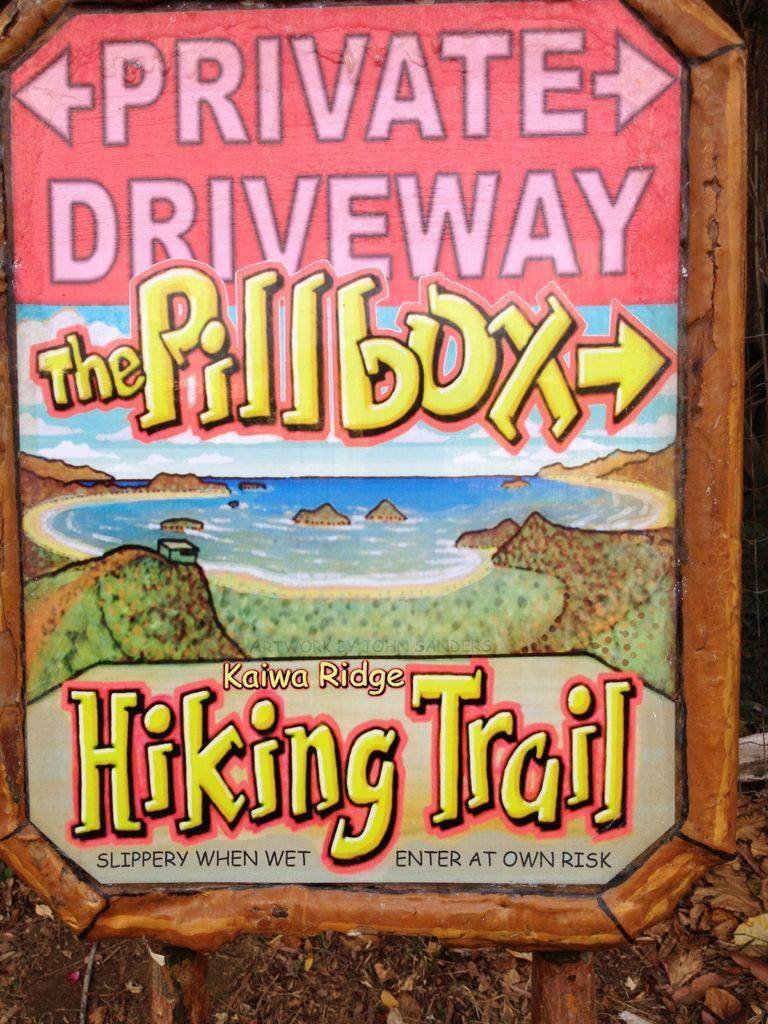<image>
Present a compact description of the photo's key features. The sign showns a hiking trail in a place called Kaiwa Ridge. 